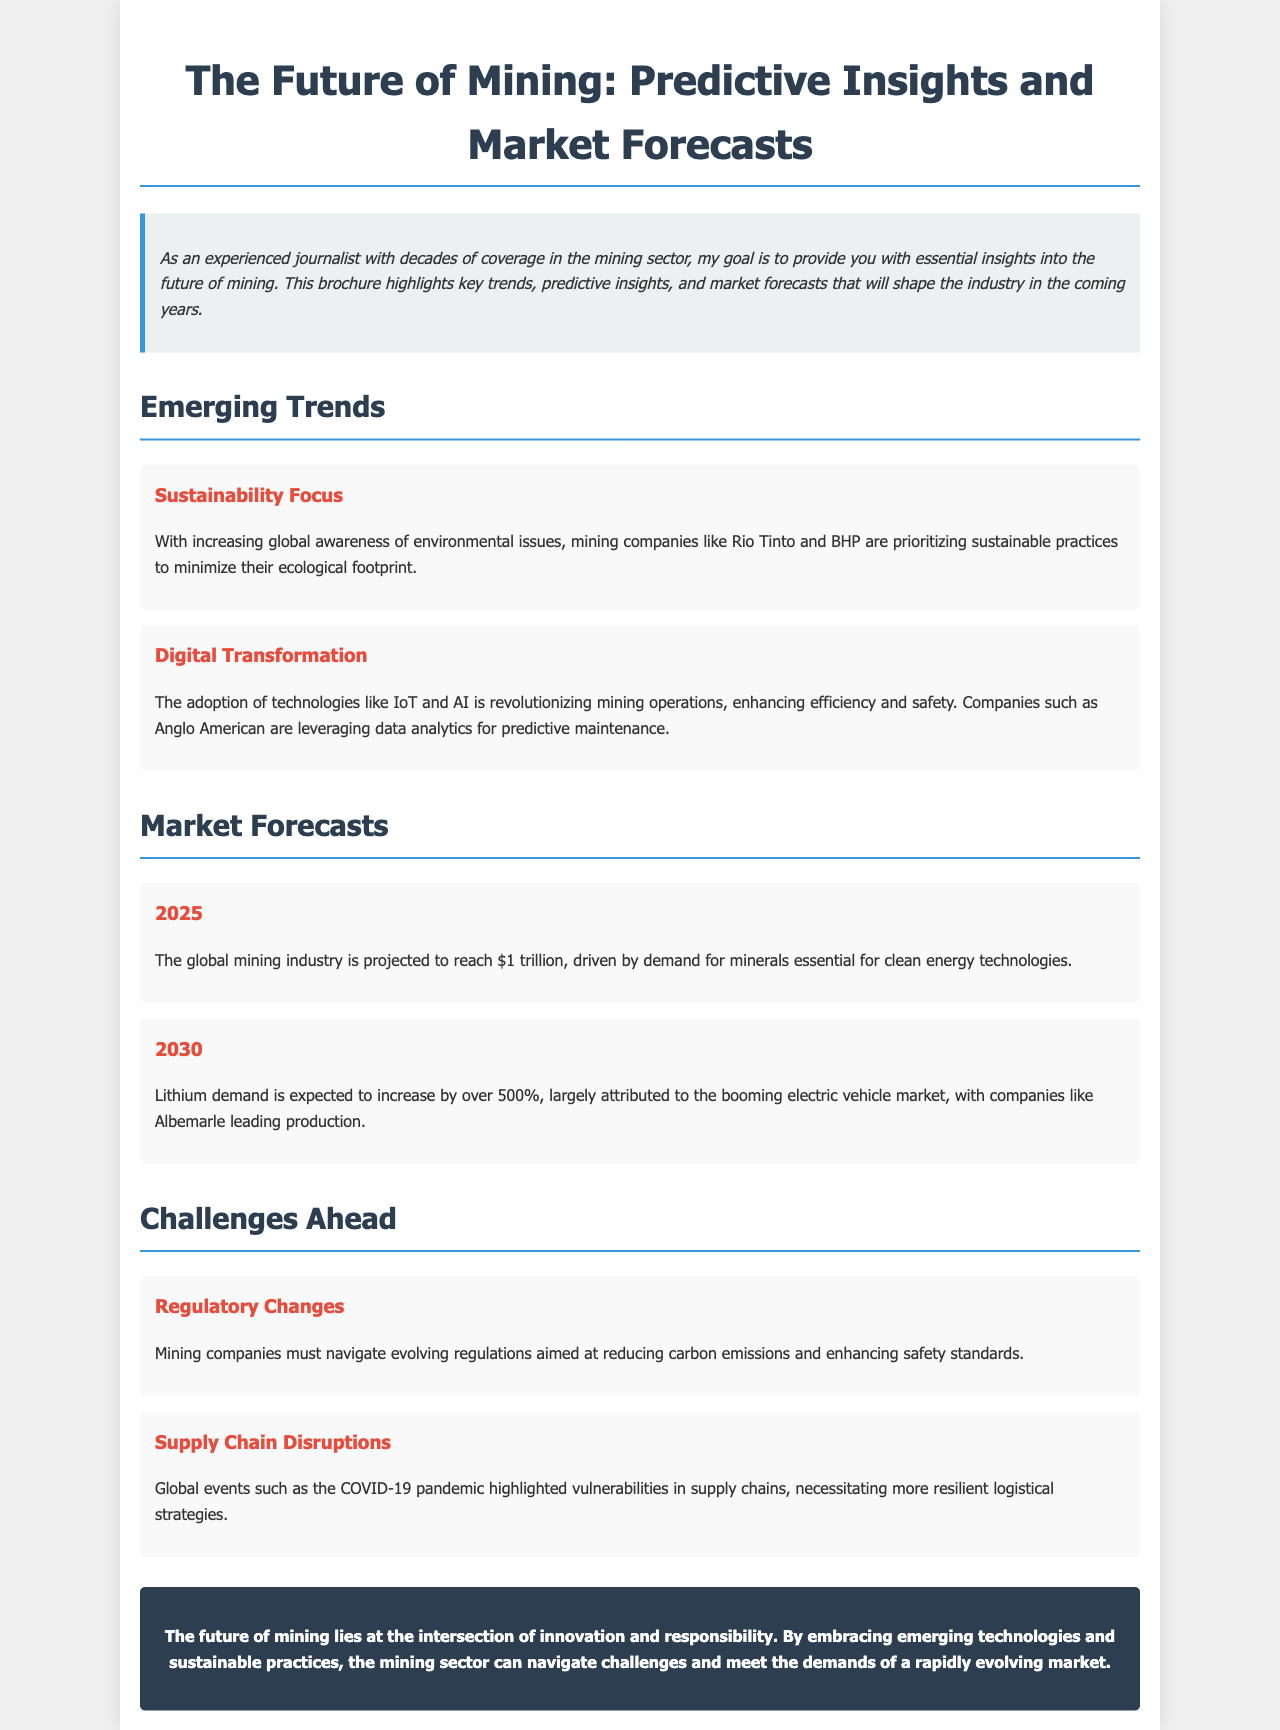What is the main theme of the brochure? The brochure focuses on key trends, predictive insights, and market forecasts that will shape the mining industry.
Answer: Future of Mining Which company is mentioned in relation to sustainability focus? The document states that Rio Tinto and BHP are prioritizing sustainable practices.
Answer: Rio Tinto and BHP What is the projected value of the global mining industry by 2025? The forecast highlights that the global mining industry is projected to reach $1 trillion.
Answer: $1 trillion By how much is lithium demand expected to increase by 2030? The document indicates that lithium demand is expected to increase by over 500%.
Answer: Over 500% What challenge do mining companies face regarding regulations? It states that mining companies must navigate evolving regulations aimed at reducing carbon emissions.
Answer: Regulatory Changes What technological advancements are mentioned as part of digital transformation? The brochure mentions the adoption of technologies like IoT and AI for enhancing efficiency and safety.
Answer: IoT and AI What significant global event highlighted supply chain vulnerabilities? The document notes that the COVID-19 pandemic highlighted these vulnerabilities.
Answer: COVID-19 pandemic What is the conclusion about the future of mining? The conclusion emphasizes innovation and responsibility in navigating challenges and meeting market demands.
Answer: Innovation and responsibility 